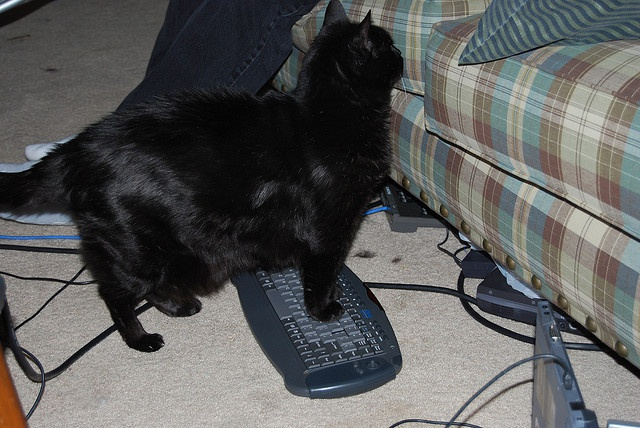Describe the objects in this image and their specific colors. I can see cat in blue, black, gray, and darkgray tones, couch in blue, gray, and darkgray tones, keyboard in blue, black, gray, and darkblue tones, people in blue, black, gray, and darkgray tones, and laptop in blue, black, and gray tones in this image. 